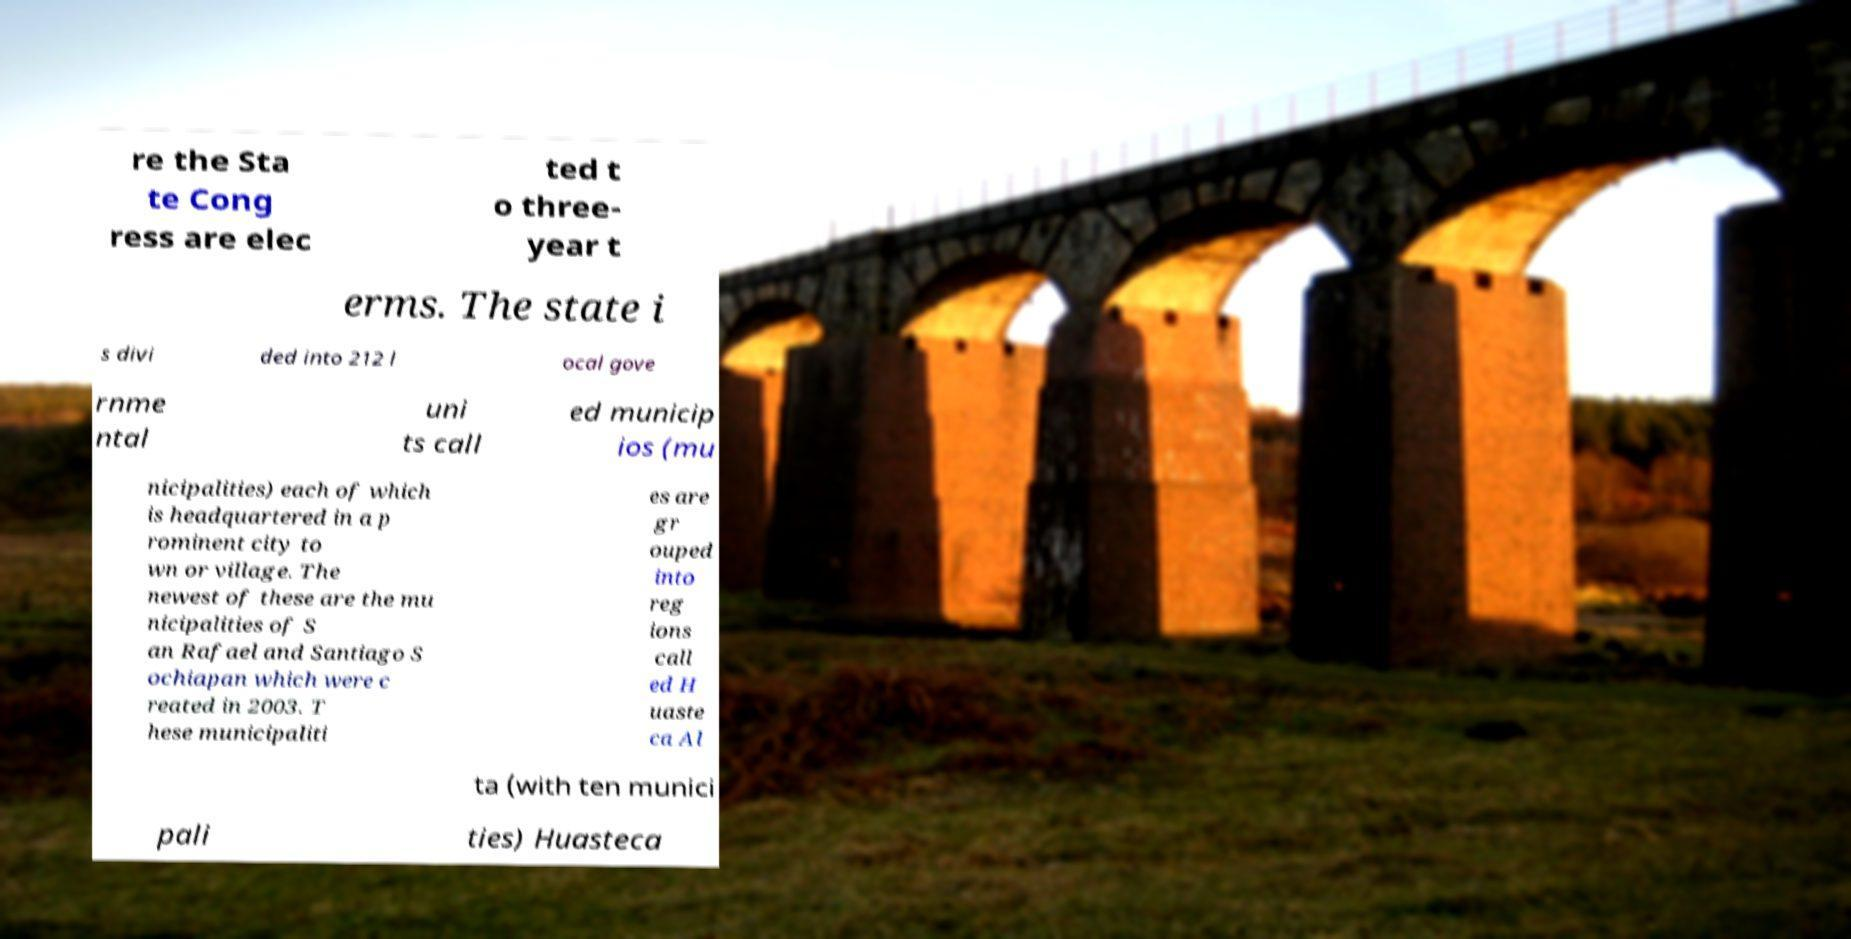I need the written content from this picture converted into text. Can you do that? re the Sta te Cong ress are elec ted t o three- year t erms. The state i s divi ded into 212 l ocal gove rnme ntal uni ts call ed municip ios (mu nicipalities) each of which is headquartered in a p rominent city to wn or village. The newest of these are the mu nicipalities of S an Rafael and Santiago S ochiapan which were c reated in 2003. T hese municipaliti es are gr ouped into reg ions call ed H uaste ca Al ta (with ten munici pali ties) Huasteca 